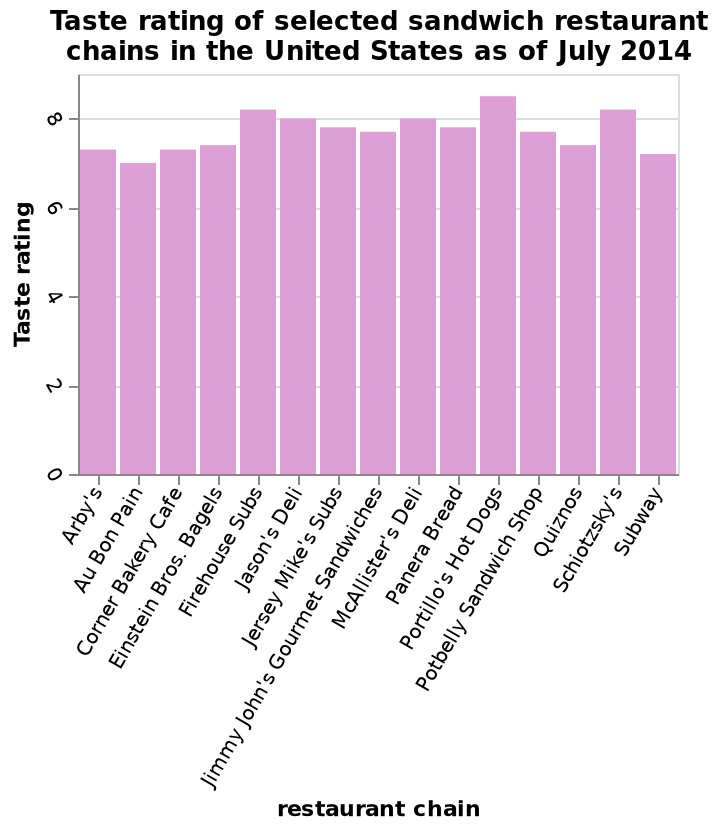<image>
Is the taste rating for Portillo's Hotdogs above 7 but below 8? No, the taste rating for Portillo's Hotdogs is above 8. 